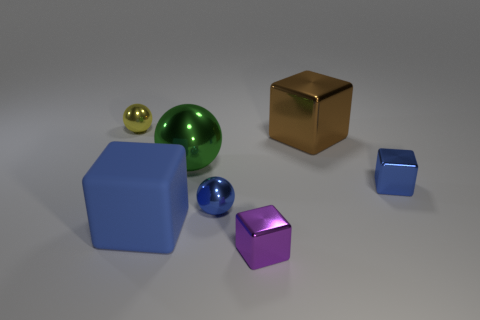Add 1 purple objects. How many objects exist? 8 Subtract all spheres. How many objects are left? 4 Add 1 tiny yellow metal spheres. How many tiny yellow metal spheres exist? 2 Subtract 1 green balls. How many objects are left? 6 Subtract all small red cylinders. Subtract all large green objects. How many objects are left? 6 Add 7 large green balls. How many large green balls are left? 8 